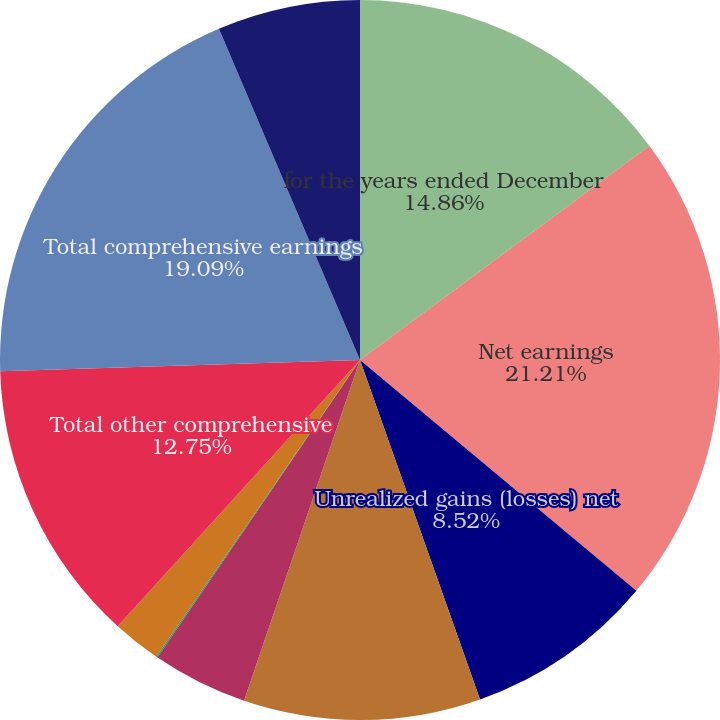<chart> <loc_0><loc_0><loc_500><loc_500><pie_chart><fcel>for the years ended December<fcel>Net earnings<fcel>Unrealized gains (losses) net<fcel>Net gains (losses) and prior<fcel>Amortization of net losses<fcel>Gains (losses) recognized net<fcel>(Gains) losses transferred to<fcel>Total other comprehensive<fcel>Total comprehensive earnings<fcel>Noncontrolling interests<nl><fcel>14.86%<fcel>21.21%<fcel>8.52%<fcel>10.63%<fcel>4.29%<fcel>0.06%<fcel>2.18%<fcel>12.75%<fcel>19.09%<fcel>6.41%<nl></chart> 